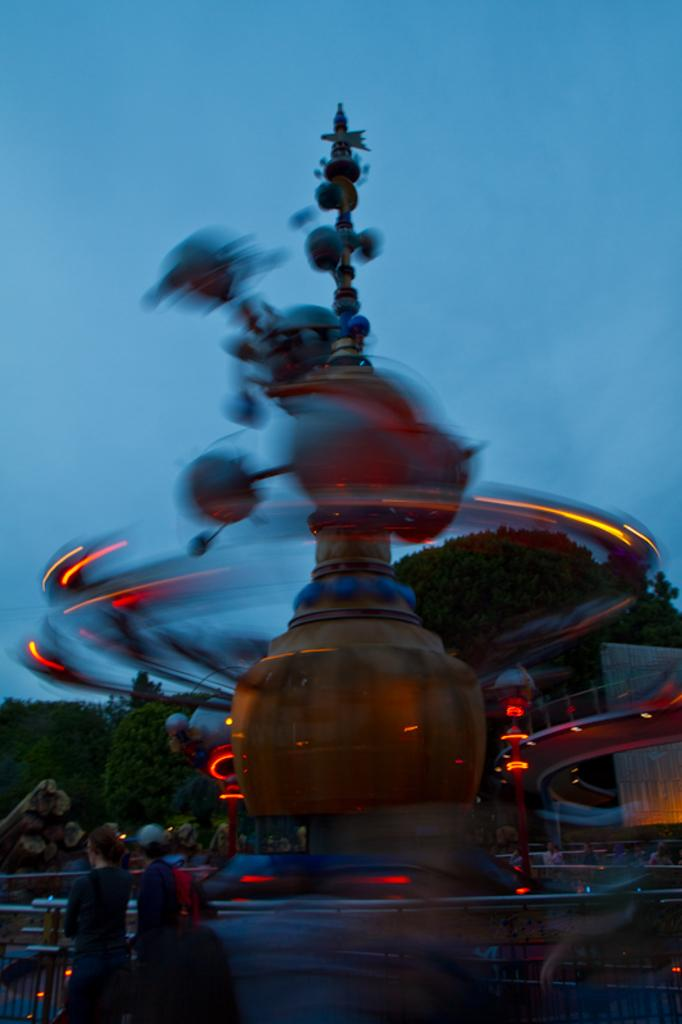What are the two people doing on the left side of the image? There is a woman and a man walking on the left side of the image. What can be seen in the middle of the image? There is an electronic machine in the middle of the image. Is the machine in operation? Yes, the machine appears to be running. What is visible at the top of the image? The sky is visible at the top of the image. How many squirrels are playing on the town's rooftops in the image? There are no squirrels or town rooftops present in the image. Are the two women in the image sisters? There are no women present in the image, only a woman and a man walking. 